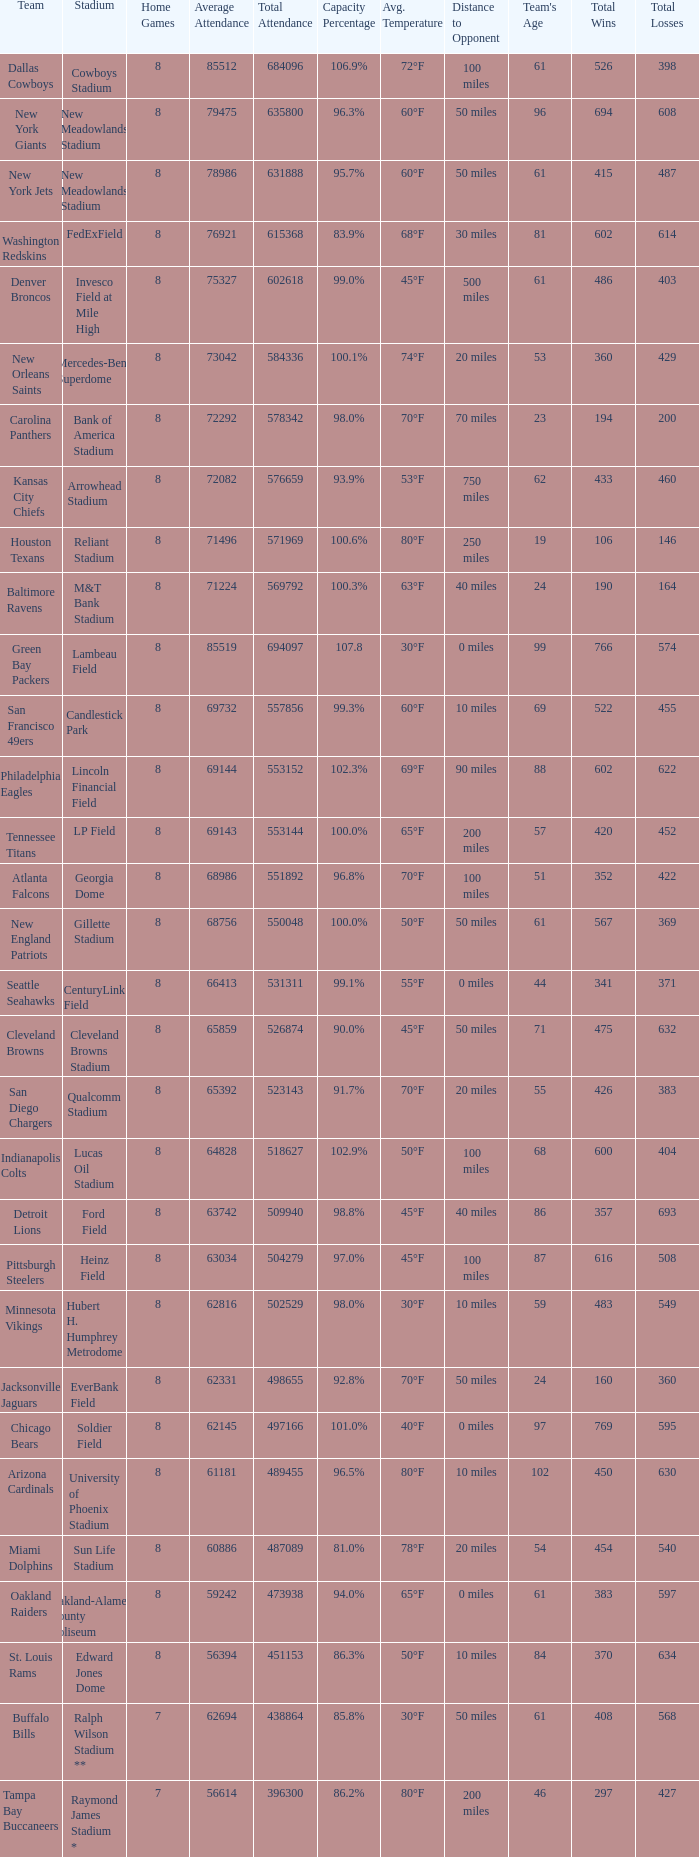What is the number listed in home games when the team is Seattle Seahawks? 8.0. 